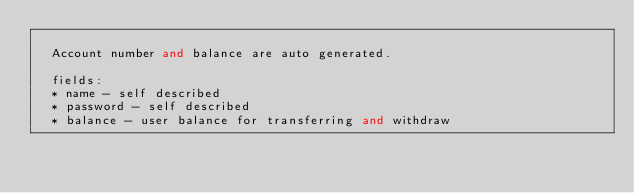<code> <loc_0><loc_0><loc_500><loc_500><_Elixir_>
  Account number and balance are auto generated.

  fields:
  * name - self described
  * password - self described
  * balance - user balance for transferring and withdraw</code> 